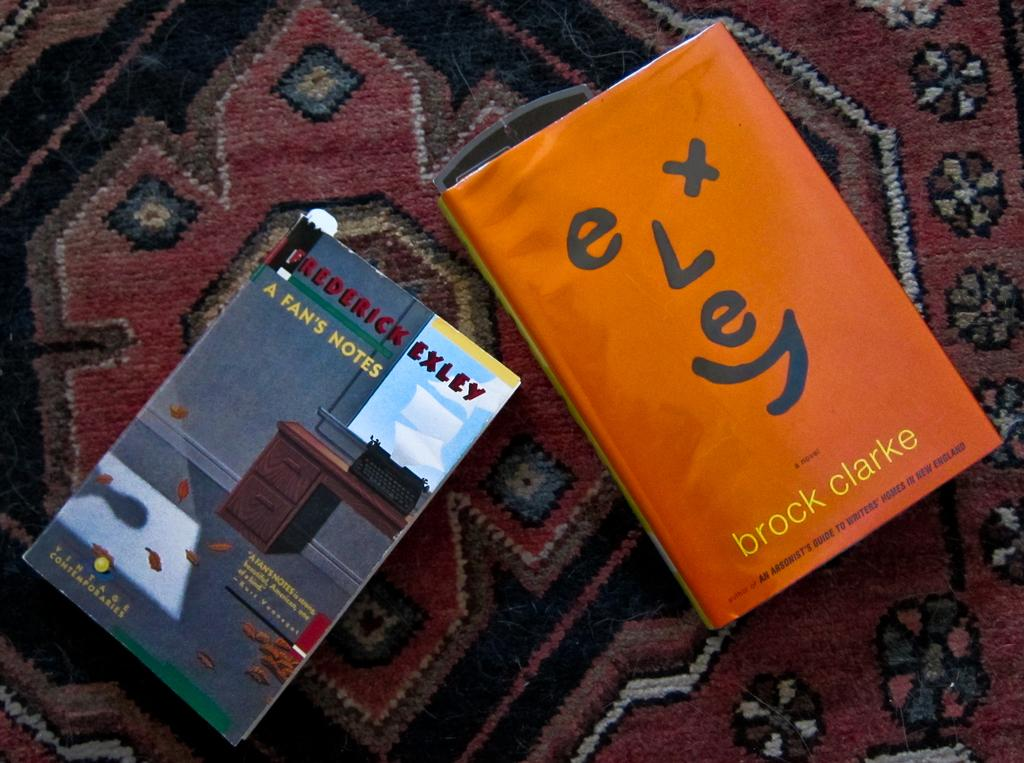<image>
Summarize the visual content of the image. A Brock Clarke book sits on a rug next to A Fan's Notes. 